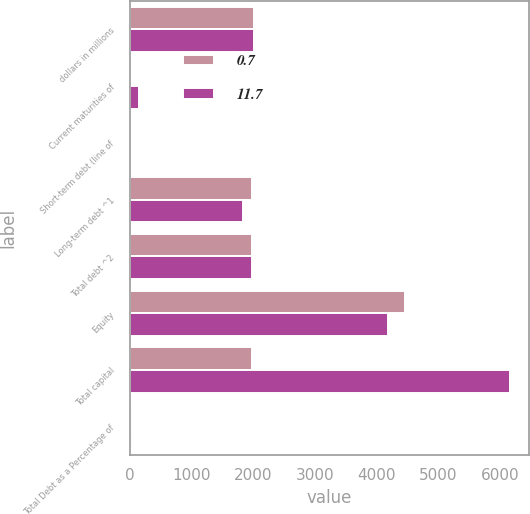<chart> <loc_0><loc_0><loc_500><loc_500><stacked_bar_chart><ecel><fcel>dollars in millions<fcel>Current maturities of<fcel>Short-term debt (line of<fcel>Long-term debt ^1<fcel>Total debt ^2<fcel>Equity<fcel>Total capital<fcel>Total Debt as a Percentage of<nl><fcel>0.7<fcel>2015<fcel>0.1<fcel>0<fcel>1980.3<fcel>1980.4<fcel>4454.2<fcel>1980.3<fcel>30.8<nl><fcel>11.7<fcel>2014<fcel>150.1<fcel>0<fcel>1834.6<fcel>1984.7<fcel>4176.7<fcel>6161.4<fcel>32.2<nl></chart> 